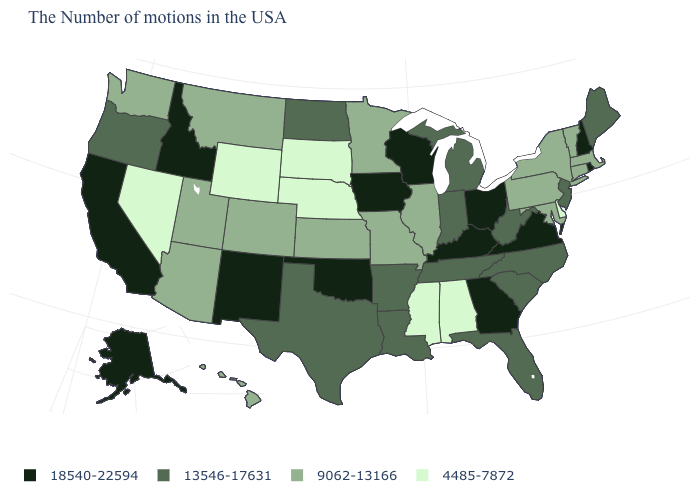Among the states that border North Dakota , which have the lowest value?
Be succinct. South Dakota. What is the value of Pennsylvania?
Concise answer only. 9062-13166. What is the highest value in the USA?
Short answer required. 18540-22594. What is the value of Idaho?
Keep it brief. 18540-22594. Which states hav the highest value in the West?
Quick response, please. New Mexico, Idaho, California, Alaska. What is the value of Delaware?
Short answer required. 4485-7872. Among the states that border North Carolina , does Virginia have the lowest value?
Quick response, please. No. What is the value of Maine?
Short answer required. 13546-17631. What is the lowest value in the USA?
Write a very short answer. 4485-7872. What is the lowest value in the West?
Short answer required. 4485-7872. What is the highest value in states that border Nebraska?
Quick response, please. 18540-22594. Which states have the lowest value in the West?
Give a very brief answer. Wyoming, Nevada. What is the lowest value in the USA?
Keep it brief. 4485-7872. Does the map have missing data?
Concise answer only. No. What is the lowest value in states that border Indiana?
Quick response, please. 9062-13166. 